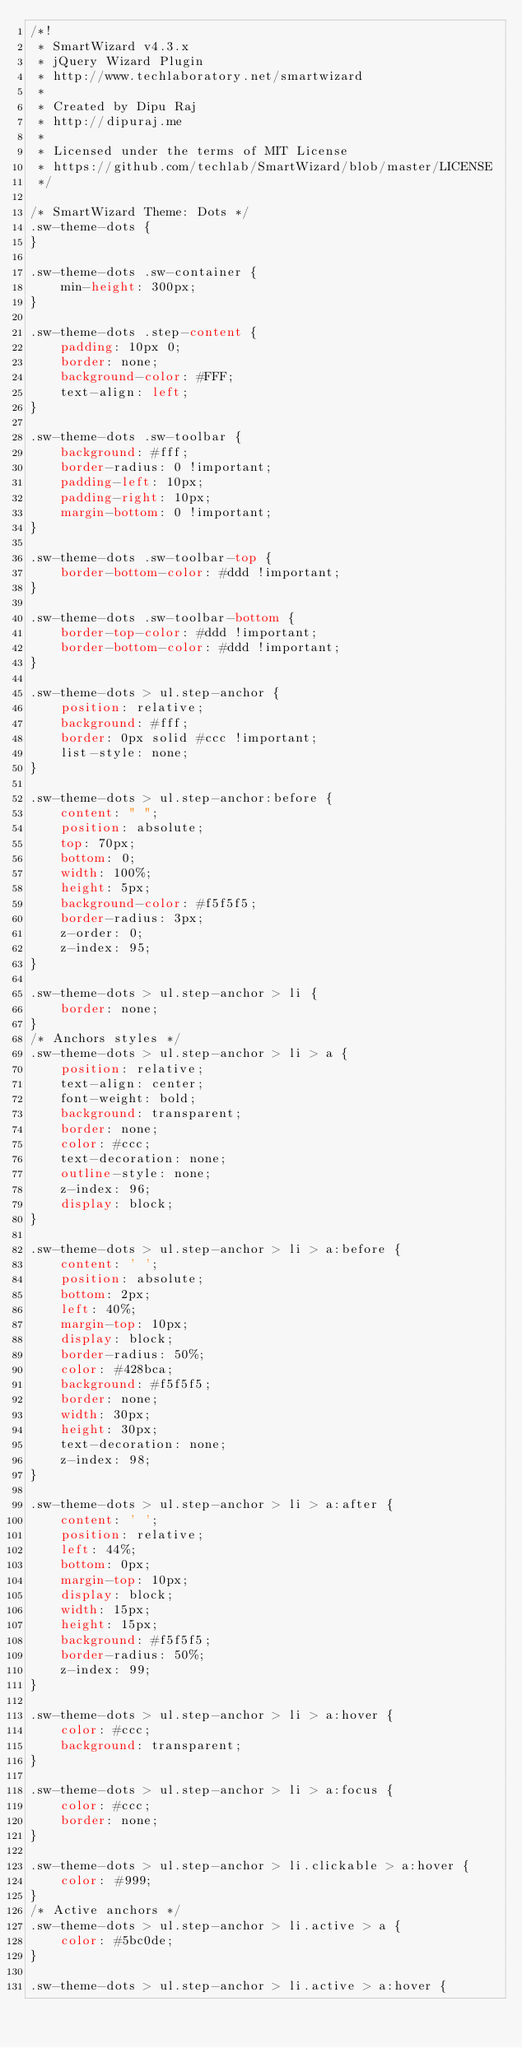<code> <loc_0><loc_0><loc_500><loc_500><_CSS_>/*!
 * SmartWizard v4.3.x
 * jQuery Wizard Plugin
 * http://www.techlaboratory.net/smartwizard
 *
 * Created by Dipu Raj
 * http://dipuraj.me
 *
 * Licensed under the terms of MIT License
 * https://github.com/techlab/SmartWizard/blob/master/LICENSE
 */

/* SmartWizard Theme: Dots */
.sw-theme-dots {
}

.sw-theme-dots .sw-container {
	min-height: 300px;
}

.sw-theme-dots .step-content {
	padding: 10px 0;
	border: none;
	background-color: #FFF;
	text-align: left;
}

.sw-theme-dots .sw-toolbar {
	background: #fff;
	border-radius: 0 !important;
	padding-left: 10px;
	padding-right: 10px;
	margin-bottom: 0 !important;
}

.sw-theme-dots .sw-toolbar-top {
	border-bottom-color: #ddd !important;
}

.sw-theme-dots .sw-toolbar-bottom {
	border-top-color: #ddd !important;
	border-bottom-color: #ddd !important;
}

.sw-theme-dots > ul.step-anchor {
	position: relative;
	background: #fff;
	border: 0px solid #ccc !important;
	list-style: none;
}

.sw-theme-dots > ul.step-anchor:before {
	content: " ";
	position: absolute;
	top: 70px;
	bottom: 0;
	width: 100%;
	height: 5px;
	background-color: #f5f5f5;
	border-radius: 3px;
	z-order: 0;
	z-index: 95;
}

.sw-theme-dots > ul.step-anchor > li {
	border: none;
}
/* Anchors styles */
.sw-theme-dots > ul.step-anchor > li > a {
	position: relative;
	text-align: center;
	font-weight: bold;
	background: transparent;
	border: none;
	color: #ccc;
	text-decoration: none;
	outline-style: none;
	z-index: 96;
	display: block;
}

.sw-theme-dots > ul.step-anchor > li > a:before {
	content: ' ';
	position: absolute;
	bottom: 2px;
	left: 40%;
	margin-top: 10px;
	display: block;
	border-radius: 50%;
	color: #428bca;
	background: #f5f5f5;
	border: none;
	width: 30px;
	height: 30px;
	text-decoration: none;
	z-index: 98;
}

.sw-theme-dots > ul.step-anchor > li > a:after {
	content: ' ';
	position: relative;
	left: 44%;
	bottom: 0px;
	margin-top: 10px;
	display: block;
	width: 15px;
	height: 15px;
	background: #f5f5f5;
	border-radius: 50%;
	z-index: 99;
}

.sw-theme-dots > ul.step-anchor > li > a:hover {
	color: #ccc;
	background: transparent;
}

.sw-theme-dots > ul.step-anchor > li > a:focus {
	color: #ccc;
	border: none;
}

.sw-theme-dots > ul.step-anchor > li.clickable > a:hover {
	color: #999;
}
/* Active anchors */
.sw-theme-dots > ul.step-anchor > li.active > a {
	color: #5bc0de;
}

.sw-theme-dots > ul.step-anchor > li.active > a:hover {</code> 